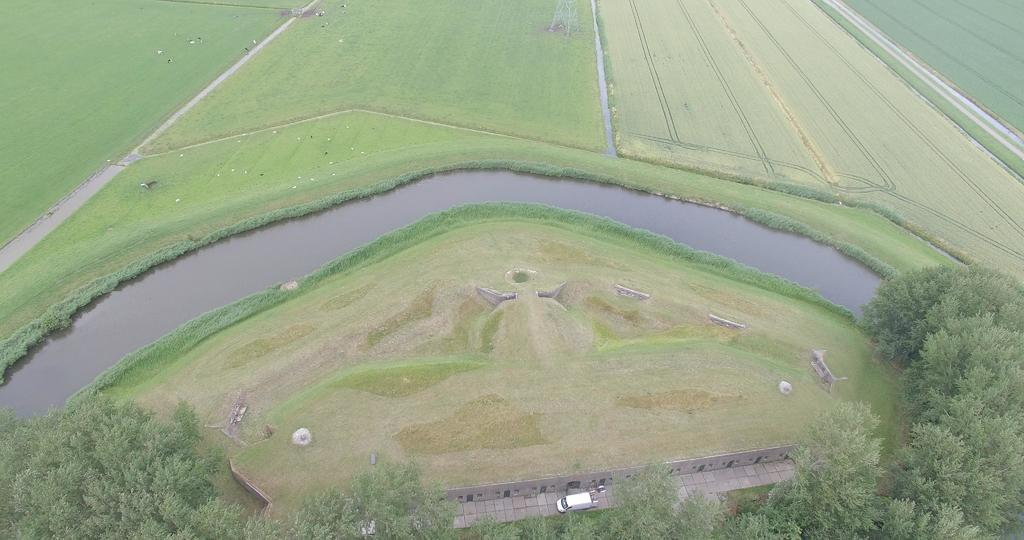What is located at the bottom of the image? There is a vehicle at the bottom of the image. What can be seen on either side of the vehicle? There are trees on either side of the vehicle. What is in the middle of the image? There is a canal in the middle of the image. What is growing beside the canal? Crops are present beside the canal. What type of plastic is used to guide the vehicle in the image? There is no plastic used to guide the vehicle in the image; it appears to be driving on a road or path. 